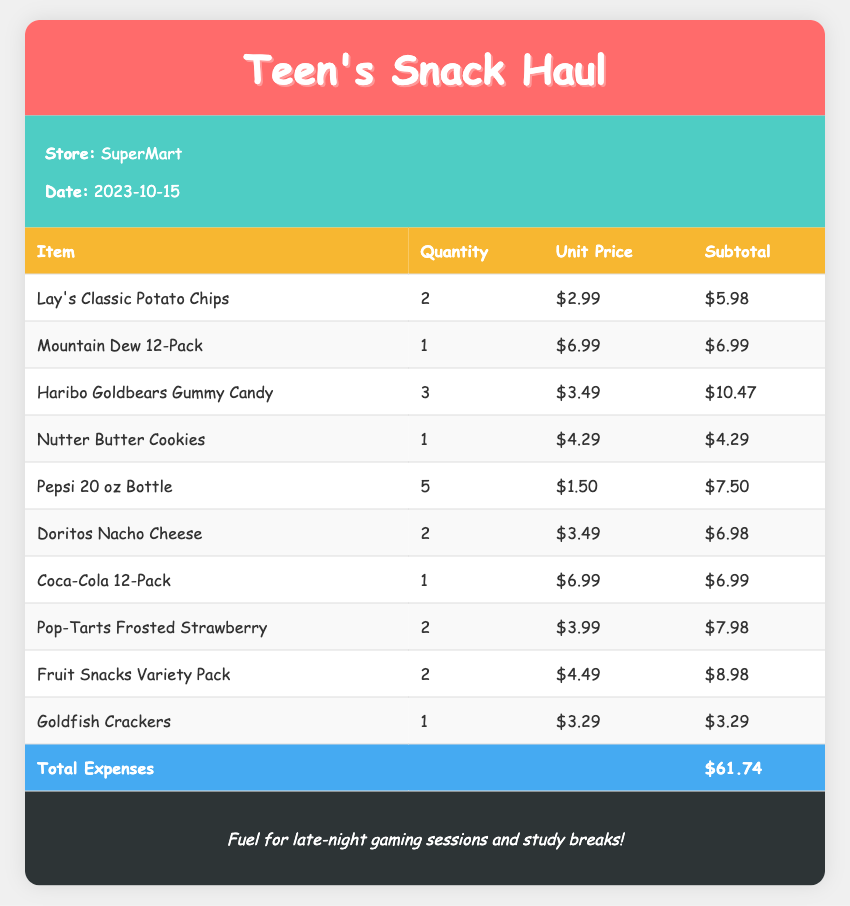What is the date of the receipt? The date of the receipt is provided in the document under the receipt info section.
Answer: 2023-10-15 How many Lay's Classic Potato Chips were purchased? The quantity of Lay's Classic Potato Chips is stated in the itemized list.
Answer: 2 What is the unit price of Mountain Dew 12-Pack? The unit price of the Mountain Dew 12-Pack can be found in the table under the respective column.
Answer: $6.99 What is the subtotal for Haribo Goldbears Gummy Candy? The subtotal for Haribo Goldbears is indicated in the table next to the item.
Answer: $10.47 What is the total amount spent on snacks and drinks? The total expenses are summarized at the bottom of the table.
Answer: $61.74 Which item has the highest unit price? To determine this, we compare the unit prices listed in the document.
Answer: $4.49 (Fruit Snacks Variety Pack) How many different types of drinks were purchased? The total number of drinks can be counted from the itemized list in the document.
Answer: 3 What is the subtotal for the Nutter Butter Cookies? The subtotal for Nutter Butter Cookies is available in the table under the subtotal column.
Answer: $4.29 What store was the shopping done at? The store name can be found in the receipt info section at the top of the document.
Answer: SuperMart 